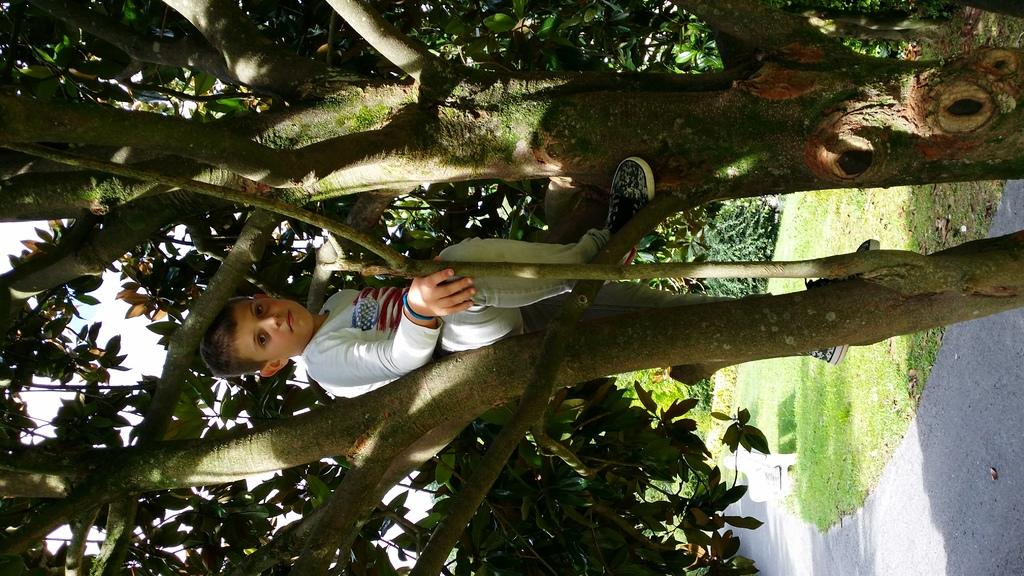What is the boy doing in the image? The boy is sitting on a tree in the image. What type of vegetation is at the bottom of the image? There is grass at the bottom of the image. What kind of path can be seen in the image? There is a walkway visible in the image. What effect does the moon have on the boy in the image? The image does not show the moon, so it is not possible to determine any effect it might have on the boy. 